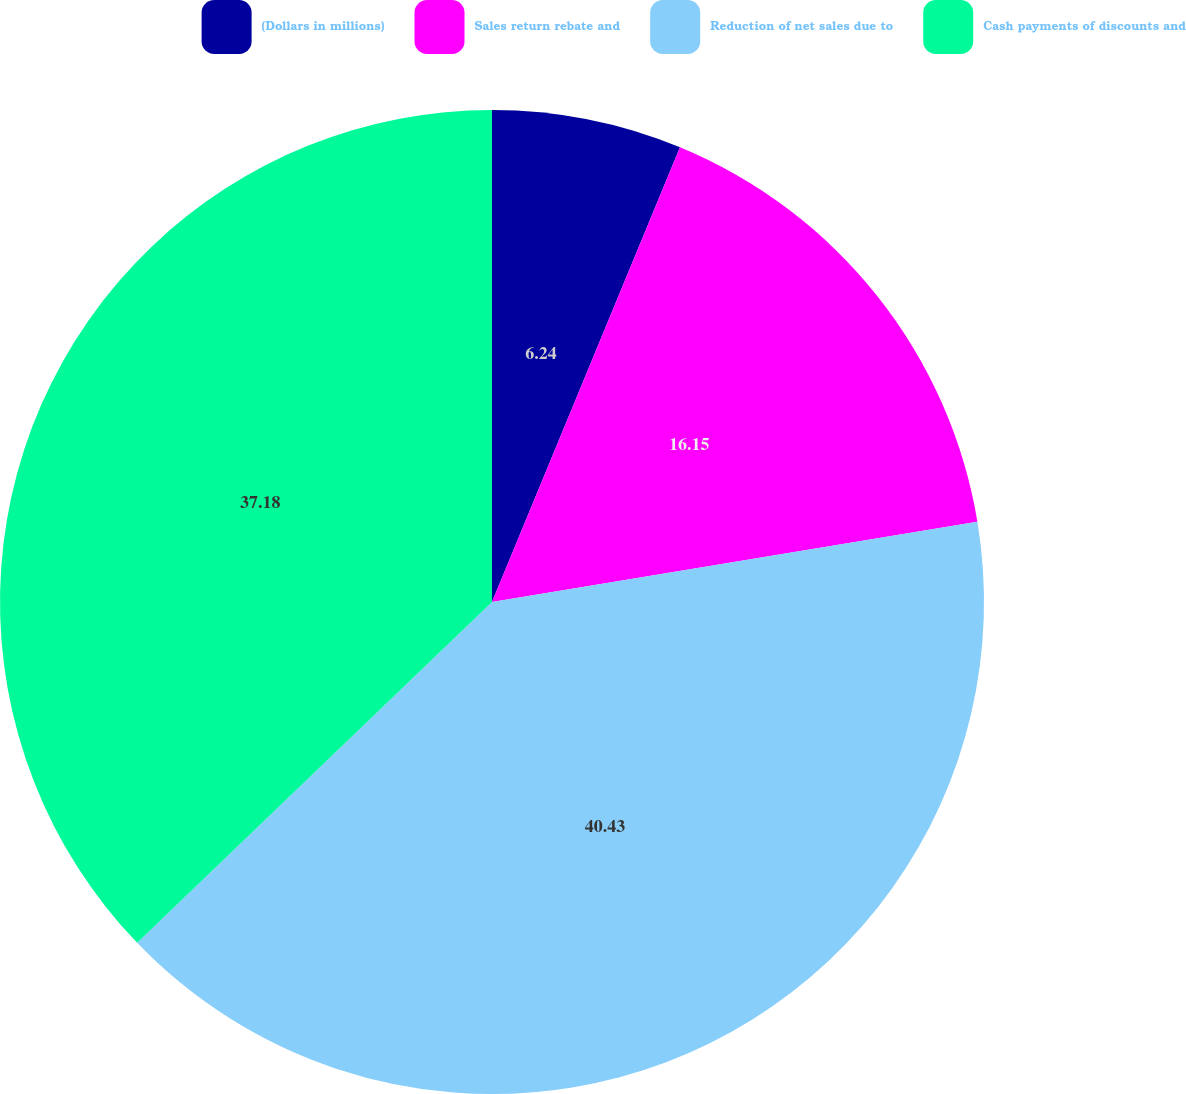Convert chart to OTSL. <chart><loc_0><loc_0><loc_500><loc_500><pie_chart><fcel>(Dollars in millions)<fcel>Sales return rebate and<fcel>Reduction of net sales due to<fcel>Cash payments of discounts and<nl><fcel>6.24%<fcel>16.15%<fcel>40.43%<fcel>37.18%<nl></chart> 